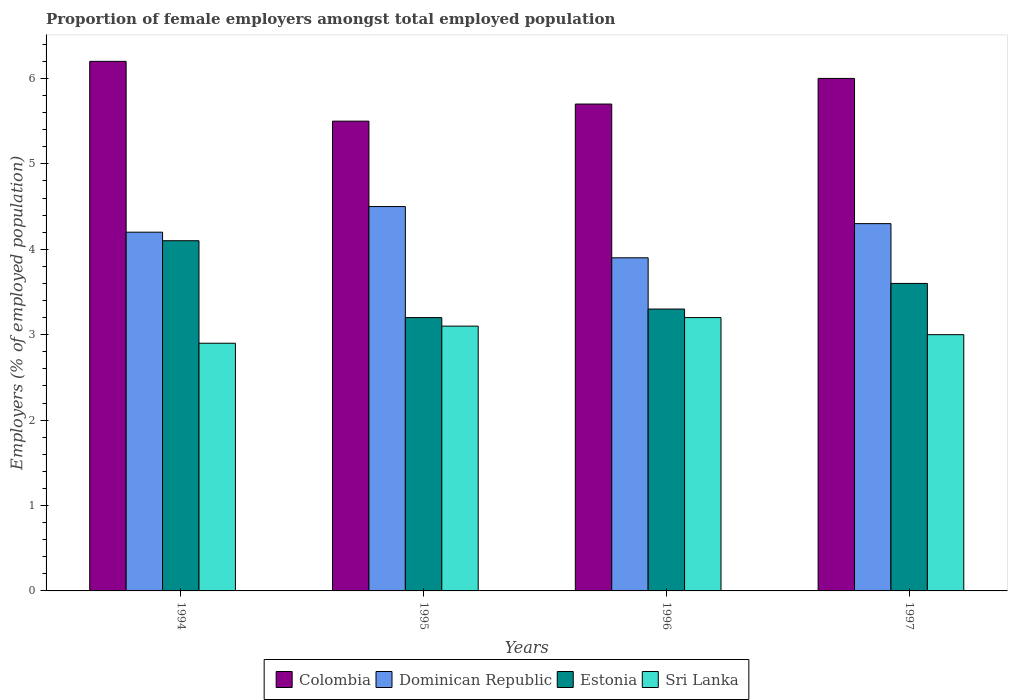How many bars are there on the 2nd tick from the left?
Make the answer very short. 4. What is the label of the 4th group of bars from the left?
Offer a very short reply. 1997. In how many cases, is the number of bars for a given year not equal to the number of legend labels?
Make the answer very short. 0. What is the proportion of female employers in Dominican Republic in 1994?
Your answer should be very brief. 4.2. Across all years, what is the maximum proportion of female employers in Sri Lanka?
Ensure brevity in your answer.  3.2. Across all years, what is the minimum proportion of female employers in Estonia?
Keep it short and to the point. 3.2. In which year was the proportion of female employers in Dominican Republic maximum?
Give a very brief answer. 1995. In which year was the proportion of female employers in Dominican Republic minimum?
Make the answer very short. 1996. What is the total proportion of female employers in Estonia in the graph?
Ensure brevity in your answer.  14.2. What is the difference between the proportion of female employers in Estonia in 1994 and that in 1996?
Ensure brevity in your answer.  0.8. What is the difference between the proportion of female employers in Dominican Republic in 1994 and the proportion of female employers in Estonia in 1995?
Offer a very short reply. 1. What is the average proportion of female employers in Estonia per year?
Offer a very short reply. 3.55. In the year 1997, what is the difference between the proportion of female employers in Dominican Republic and proportion of female employers in Colombia?
Ensure brevity in your answer.  -1.7. What is the ratio of the proportion of female employers in Estonia in 1995 to that in 1996?
Offer a very short reply. 0.97. Is the proportion of female employers in Dominican Republic in 1995 less than that in 1997?
Offer a terse response. No. Is the difference between the proportion of female employers in Dominican Republic in 1994 and 1997 greater than the difference between the proportion of female employers in Colombia in 1994 and 1997?
Ensure brevity in your answer.  No. What is the difference between the highest and the second highest proportion of female employers in Dominican Republic?
Your answer should be compact. 0.2. What is the difference between the highest and the lowest proportion of female employers in Estonia?
Offer a terse response. 0.9. Is the sum of the proportion of female employers in Estonia in 1995 and 1996 greater than the maximum proportion of female employers in Colombia across all years?
Make the answer very short. Yes. Is it the case that in every year, the sum of the proportion of female employers in Estonia and proportion of female employers in Dominican Republic is greater than the sum of proportion of female employers in Colombia and proportion of female employers in Sri Lanka?
Your response must be concise. No. What does the 1st bar from the left in 1994 represents?
Your response must be concise. Colombia. What does the 1st bar from the right in 1994 represents?
Your answer should be very brief. Sri Lanka. How many years are there in the graph?
Offer a terse response. 4. What is the difference between two consecutive major ticks on the Y-axis?
Your answer should be compact. 1. Are the values on the major ticks of Y-axis written in scientific E-notation?
Offer a terse response. No. Where does the legend appear in the graph?
Provide a short and direct response. Bottom center. How are the legend labels stacked?
Your answer should be compact. Horizontal. What is the title of the graph?
Offer a very short reply. Proportion of female employers amongst total employed population. What is the label or title of the Y-axis?
Make the answer very short. Employers (% of employed population). What is the Employers (% of employed population) in Colombia in 1994?
Keep it short and to the point. 6.2. What is the Employers (% of employed population) in Dominican Republic in 1994?
Offer a terse response. 4.2. What is the Employers (% of employed population) in Estonia in 1994?
Your answer should be very brief. 4.1. What is the Employers (% of employed population) in Sri Lanka in 1994?
Give a very brief answer. 2.9. What is the Employers (% of employed population) in Dominican Republic in 1995?
Offer a very short reply. 4.5. What is the Employers (% of employed population) in Estonia in 1995?
Your response must be concise. 3.2. What is the Employers (% of employed population) of Sri Lanka in 1995?
Give a very brief answer. 3.1. What is the Employers (% of employed population) of Colombia in 1996?
Give a very brief answer. 5.7. What is the Employers (% of employed population) of Dominican Republic in 1996?
Provide a succinct answer. 3.9. What is the Employers (% of employed population) in Estonia in 1996?
Your answer should be very brief. 3.3. What is the Employers (% of employed population) in Sri Lanka in 1996?
Offer a very short reply. 3.2. What is the Employers (% of employed population) in Colombia in 1997?
Your response must be concise. 6. What is the Employers (% of employed population) of Dominican Republic in 1997?
Offer a terse response. 4.3. What is the Employers (% of employed population) of Estonia in 1997?
Provide a succinct answer. 3.6. Across all years, what is the maximum Employers (% of employed population) of Colombia?
Keep it short and to the point. 6.2. Across all years, what is the maximum Employers (% of employed population) of Dominican Republic?
Ensure brevity in your answer.  4.5. Across all years, what is the maximum Employers (% of employed population) of Estonia?
Offer a very short reply. 4.1. Across all years, what is the maximum Employers (% of employed population) of Sri Lanka?
Ensure brevity in your answer.  3.2. Across all years, what is the minimum Employers (% of employed population) of Colombia?
Provide a succinct answer. 5.5. Across all years, what is the minimum Employers (% of employed population) in Dominican Republic?
Your answer should be compact. 3.9. Across all years, what is the minimum Employers (% of employed population) of Estonia?
Keep it short and to the point. 3.2. Across all years, what is the minimum Employers (% of employed population) in Sri Lanka?
Give a very brief answer. 2.9. What is the total Employers (% of employed population) in Colombia in the graph?
Offer a terse response. 23.4. What is the total Employers (% of employed population) of Estonia in the graph?
Give a very brief answer. 14.2. What is the total Employers (% of employed population) in Sri Lanka in the graph?
Your answer should be very brief. 12.2. What is the difference between the Employers (% of employed population) in Colombia in 1994 and that in 1996?
Your answer should be compact. 0.5. What is the difference between the Employers (% of employed population) of Estonia in 1994 and that in 1996?
Provide a short and direct response. 0.8. What is the difference between the Employers (% of employed population) of Sri Lanka in 1994 and that in 1996?
Your answer should be compact. -0.3. What is the difference between the Employers (% of employed population) of Dominican Republic in 1994 and that in 1997?
Provide a short and direct response. -0.1. What is the difference between the Employers (% of employed population) in Estonia in 1994 and that in 1997?
Ensure brevity in your answer.  0.5. What is the difference between the Employers (% of employed population) of Colombia in 1995 and that in 1996?
Give a very brief answer. -0.2. What is the difference between the Employers (% of employed population) of Dominican Republic in 1995 and that in 1996?
Offer a terse response. 0.6. What is the difference between the Employers (% of employed population) in Estonia in 1995 and that in 1996?
Ensure brevity in your answer.  -0.1. What is the difference between the Employers (% of employed population) in Sri Lanka in 1995 and that in 1996?
Make the answer very short. -0.1. What is the difference between the Employers (% of employed population) in Colombia in 1995 and that in 1997?
Provide a succinct answer. -0.5. What is the difference between the Employers (% of employed population) of Sri Lanka in 1995 and that in 1997?
Your response must be concise. 0.1. What is the difference between the Employers (% of employed population) of Dominican Republic in 1996 and that in 1997?
Your response must be concise. -0.4. What is the difference between the Employers (% of employed population) in Estonia in 1996 and that in 1997?
Give a very brief answer. -0.3. What is the difference between the Employers (% of employed population) of Colombia in 1994 and the Employers (% of employed population) of Sri Lanka in 1995?
Your answer should be compact. 3.1. What is the difference between the Employers (% of employed population) of Dominican Republic in 1994 and the Employers (% of employed population) of Sri Lanka in 1995?
Your answer should be very brief. 1.1. What is the difference between the Employers (% of employed population) in Colombia in 1994 and the Employers (% of employed population) in Estonia in 1996?
Ensure brevity in your answer.  2.9. What is the difference between the Employers (% of employed population) of Dominican Republic in 1994 and the Employers (% of employed population) of Estonia in 1996?
Make the answer very short. 0.9. What is the difference between the Employers (% of employed population) of Estonia in 1994 and the Employers (% of employed population) of Sri Lanka in 1996?
Your answer should be compact. 0.9. What is the difference between the Employers (% of employed population) in Colombia in 1994 and the Employers (% of employed population) in Dominican Republic in 1997?
Ensure brevity in your answer.  1.9. What is the difference between the Employers (% of employed population) in Colombia in 1994 and the Employers (% of employed population) in Sri Lanka in 1997?
Ensure brevity in your answer.  3.2. What is the difference between the Employers (% of employed population) of Dominican Republic in 1994 and the Employers (% of employed population) of Sri Lanka in 1997?
Give a very brief answer. 1.2. What is the difference between the Employers (% of employed population) in Colombia in 1995 and the Employers (% of employed population) in Sri Lanka in 1996?
Your answer should be very brief. 2.3. What is the difference between the Employers (% of employed population) of Dominican Republic in 1995 and the Employers (% of employed population) of Estonia in 1996?
Provide a short and direct response. 1.2. What is the difference between the Employers (% of employed population) in Dominican Republic in 1995 and the Employers (% of employed population) in Sri Lanka in 1996?
Give a very brief answer. 1.3. What is the difference between the Employers (% of employed population) in Colombia in 1995 and the Employers (% of employed population) in Dominican Republic in 1997?
Give a very brief answer. 1.2. What is the difference between the Employers (% of employed population) of Colombia in 1995 and the Employers (% of employed population) of Estonia in 1997?
Give a very brief answer. 1.9. What is the difference between the Employers (% of employed population) in Colombia in 1995 and the Employers (% of employed population) in Sri Lanka in 1997?
Your response must be concise. 2.5. What is the difference between the Employers (% of employed population) of Dominican Republic in 1995 and the Employers (% of employed population) of Estonia in 1997?
Make the answer very short. 0.9. What is the difference between the Employers (% of employed population) in Dominican Republic in 1995 and the Employers (% of employed population) in Sri Lanka in 1997?
Your answer should be very brief. 1.5. What is the difference between the Employers (% of employed population) of Estonia in 1995 and the Employers (% of employed population) of Sri Lanka in 1997?
Offer a very short reply. 0.2. What is the difference between the Employers (% of employed population) in Colombia in 1996 and the Employers (% of employed population) in Dominican Republic in 1997?
Your answer should be very brief. 1.4. What is the difference between the Employers (% of employed population) of Dominican Republic in 1996 and the Employers (% of employed population) of Sri Lanka in 1997?
Keep it short and to the point. 0.9. What is the difference between the Employers (% of employed population) of Estonia in 1996 and the Employers (% of employed population) of Sri Lanka in 1997?
Ensure brevity in your answer.  0.3. What is the average Employers (% of employed population) of Colombia per year?
Provide a short and direct response. 5.85. What is the average Employers (% of employed population) in Dominican Republic per year?
Keep it short and to the point. 4.22. What is the average Employers (% of employed population) of Estonia per year?
Your answer should be compact. 3.55. What is the average Employers (% of employed population) of Sri Lanka per year?
Offer a terse response. 3.05. In the year 1994, what is the difference between the Employers (% of employed population) of Colombia and Employers (% of employed population) of Estonia?
Your response must be concise. 2.1. In the year 1994, what is the difference between the Employers (% of employed population) of Colombia and Employers (% of employed population) of Sri Lanka?
Your answer should be very brief. 3.3. In the year 1995, what is the difference between the Employers (% of employed population) of Colombia and Employers (% of employed population) of Dominican Republic?
Offer a very short reply. 1. In the year 1995, what is the difference between the Employers (% of employed population) in Colombia and Employers (% of employed population) in Estonia?
Give a very brief answer. 2.3. In the year 1995, what is the difference between the Employers (% of employed population) of Dominican Republic and Employers (% of employed population) of Estonia?
Your response must be concise. 1.3. In the year 1995, what is the difference between the Employers (% of employed population) in Dominican Republic and Employers (% of employed population) in Sri Lanka?
Ensure brevity in your answer.  1.4. In the year 1995, what is the difference between the Employers (% of employed population) in Estonia and Employers (% of employed population) in Sri Lanka?
Your answer should be very brief. 0.1. In the year 1996, what is the difference between the Employers (% of employed population) in Colombia and Employers (% of employed population) in Estonia?
Provide a short and direct response. 2.4. In the year 1996, what is the difference between the Employers (% of employed population) in Estonia and Employers (% of employed population) in Sri Lanka?
Keep it short and to the point. 0.1. In the year 1997, what is the difference between the Employers (% of employed population) of Colombia and Employers (% of employed population) of Dominican Republic?
Offer a very short reply. 1.7. In the year 1997, what is the difference between the Employers (% of employed population) of Colombia and Employers (% of employed population) of Estonia?
Ensure brevity in your answer.  2.4. What is the ratio of the Employers (% of employed population) of Colombia in 1994 to that in 1995?
Provide a short and direct response. 1.13. What is the ratio of the Employers (% of employed population) of Dominican Republic in 1994 to that in 1995?
Keep it short and to the point. 0.93. What is the ratio of the Employers (% of employed population) in Estonia in 1994 to that in 1995?
Offer a terse response. 1.28. What is the ratio of the Employers (% of employed population) of Sri Lanka in 1994 to that in 1995?
Offer a very short reply. 0.94. What is the ratio of the Employers (% of employed population) in Colombia in 1994 to that in 1996?
Your answer should be very brief. 1.09. What is the ratio of the Employers (% of employed population) of Dominican Republic in 1994 to that in 1996?
Your answer should be very brief. 1.08. What is the ratio of the Employers (% of employed population) in Estonia in 1994 to that in 1996?
Your answer should be compact. 1.24. What is the ratio of the Employers (% of employed population) of Sri Lanka in 1994 to that in 1996?
Provide a short and direct response. 0.91. What is the ratio of the Employers (% of employed population) in Colombia in 1994 to that in 1997?
Keep it short and to the point. 1.03. What is the ratio of the Employers (% of employed population) in Dominican Republic in 1994 to that in 1997?
Offer a very short reply. 0.98. What is the ratio of the Employers (% of employed population) in Estonia in 1994 to that in 1997?
Your answer should be very brief. 1.14. What is the ratio of the Employers (% of employed population) in Sri Lanka in 1994 to that in 1997?
Offer a very short reply. 0.97. What is the ratio of the Employers (% of employed population) of Colombia in 1995 to that in 1996?
Keep it short and to the point. 0.96. What is the ratio of the Employers (% of employed population) in Dominican Republic in 1995 to that in 1996?
Keep it short and to the point. 1.15. What is the ratio of the Employers (% of employed population) in Estonia in 1995 to that in 1996?
Give a very brief answer. 0.97. What is the ratio of the Employers (% of employed population) of Sri Lanka in 1995 to that in 1996?
Your answer should be very brief. 0.97. What is the ratio of the Employers (% of employed population) of Colombia in 1995 to that in 1997?
Provide a succinct answer. 0.92. What is the ratio of the Employers (% of employed population) of Dominican Republic in 1995 to that in 1997?
Keep it short and to the point. 1.05. What is the ratio of the Employers (% of employed population) in Sri Lanka in 1995 to that in 1997?
Keep it short and to the point. 1.03. What is the ratio of the Employers (% of employed population) of Dominican Republic in 1996 to that in 1997?
Offer a terse response. 0.91. What is the ratio of the Employers (% of employed population) in Estonia in 1996 to that in 1997?
Your answer should be compact. 0.92. What is the ratio of the Employers (% of employed population) of Sri Lanka in 1996 to that in 1997?
Offer a terse response. 1.07. What is the difference between the highest and the second highest Employers (% of employed population) of Sri Lanka?
Your answer should be very brief. 0.1. What is the difference between the highest and the lowest Employers (% of employed population) of Dominican Republic?
Your response must be concise. 0.6. What is the difference between the highest and the lowest Employers (% of employed population) of Estonia?
Your answer should be very brief. 0.9. What is the difference between the highest and the lowest Employers (% of employed population) of Sri Lanka?
Provide a short and direct response. 0.3. 